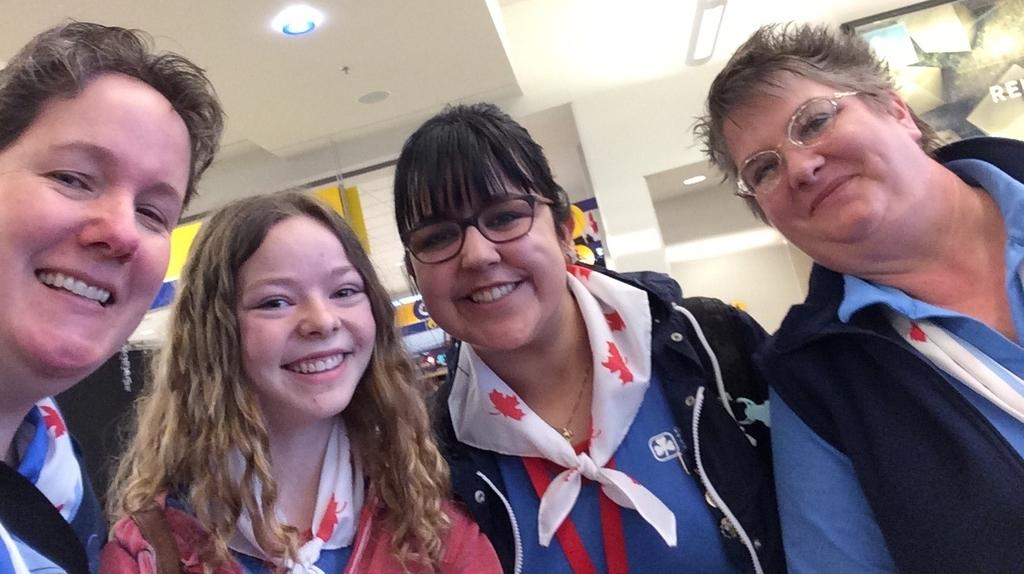How many people are present in the image? There are four persons in the image. What can be seen in the background of the image? There is a wall in the background of the image. What is visible at the top of the image? There is a roof visible at the top of the image. How many zebras can be seen grazing near the persons in the image? There are no zebras present in the image. 